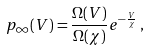Convert formula to latex. <formula><loc_0><loc_0><loc_500><loc_500>p _ { \infty } ( V ) = \frac { \Omega ( V ) } { \Omega ( \chi ) } e ^ { - \frac { V } { \chi } } \, ,</formula> 